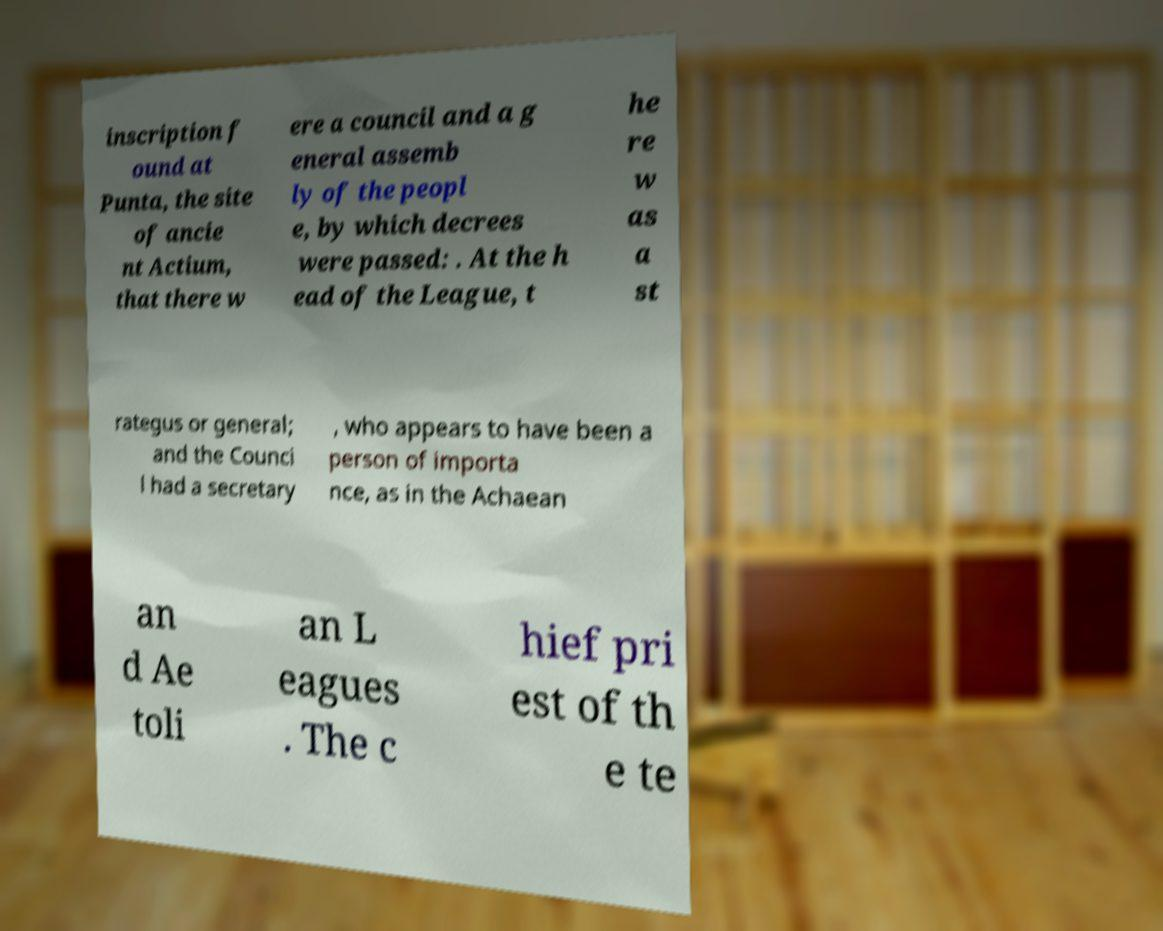Please identify and transcribe the text found in this image. inscription f ound at Punta, the site of ancie nt Actium, that there w ere a council and a g eneral assemb ly of the peopl e, by which decrees were passed: . At the h ead of the League, t he re w as a st rategus or general; and the Counci l had a secretary , who appears to have been a person of importa nce, as in the Achaean an d Ae toli an L eagues . The c hief pri est of th e te 